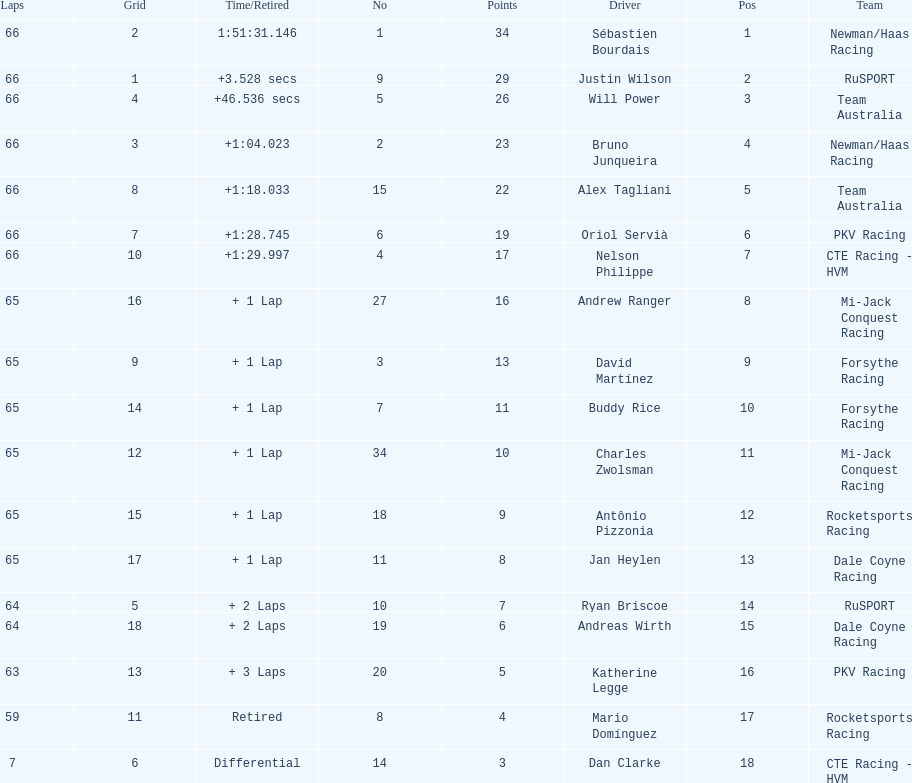At the 2006 gran premio telmex, did oriol servia or katherine legge complete more laps? Oriol Servià. 